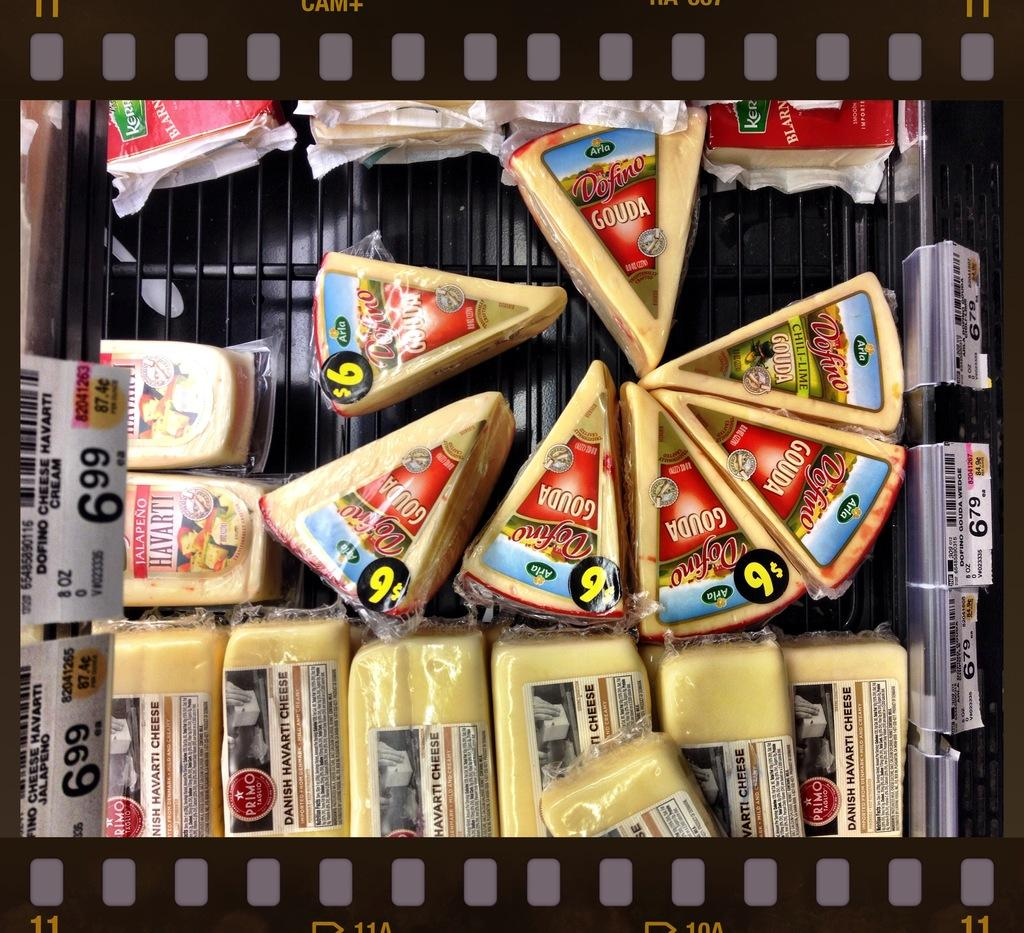Provide a one-sentence caption for the provided image. A bin full of variety of cheeses including Gouda different shapes and sizes with a price tag above for $6.99. 